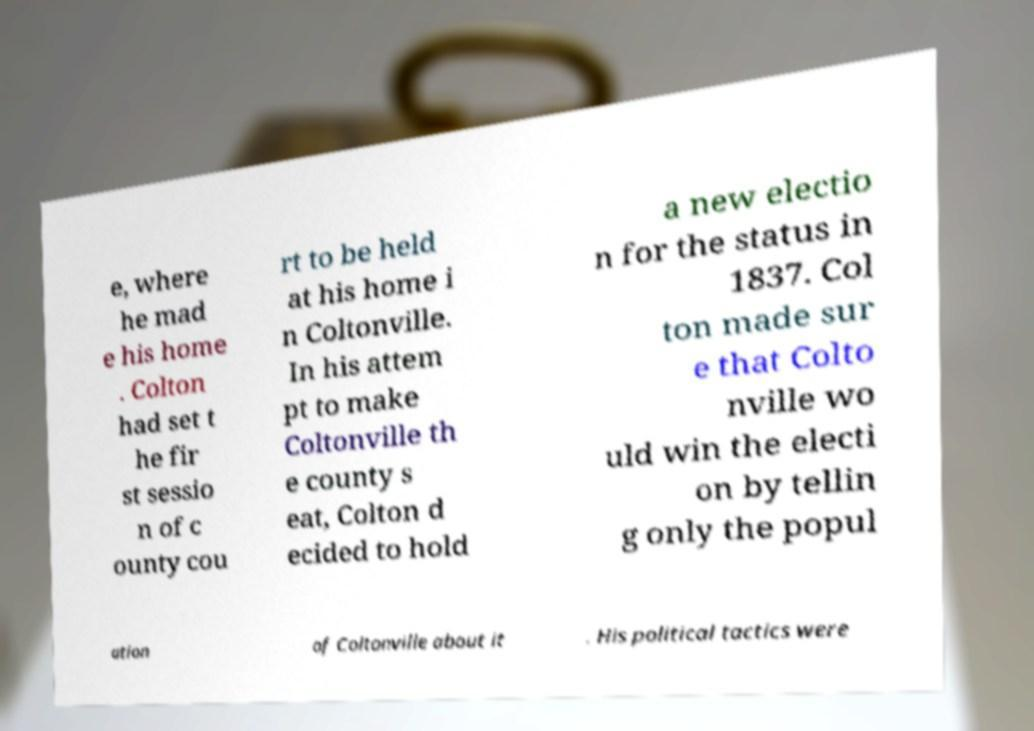Could you assist in decoding the text presented in this image and type it out clearly? e, where he mad e his home . Colton had set t he fir st sessio n of c ounty cou rt to be held at his home i n Coltonville. In his attem pt to make Coltonville th e county s eat, Colton d ecided to hold a new electio n for the status in 1837. Col ton made sur e that Colto nville wo uld win the electi on by tellin g only the popul ation of Coltonville about it . His political tactics were 